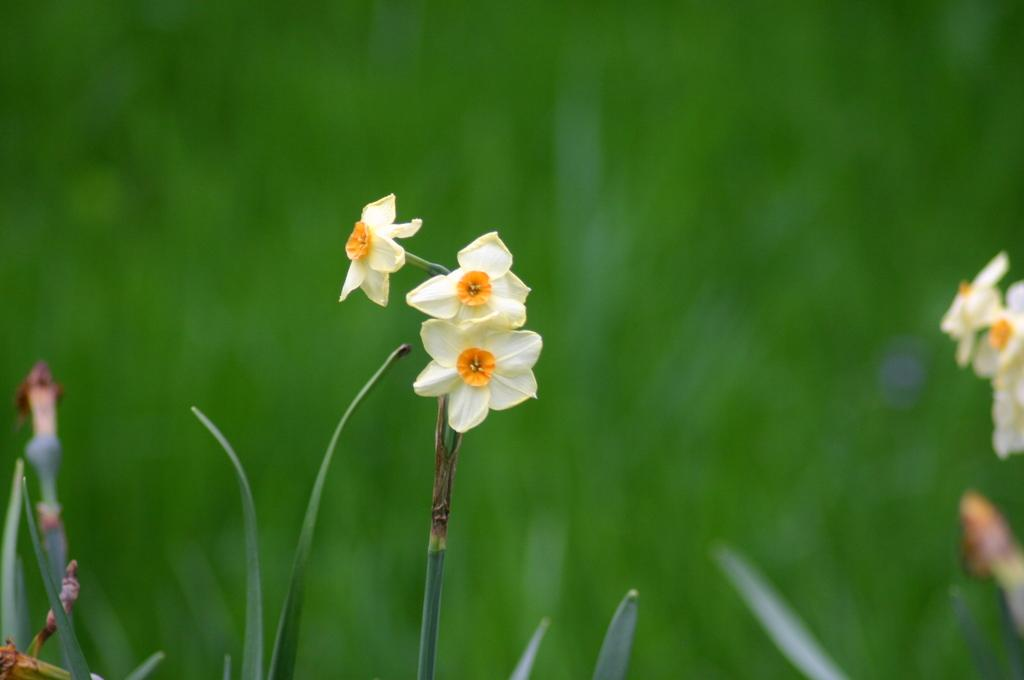What is the main subject in the middle of the image? There are flowers in the middle of the image. Can you describe the background of the image? The background of the image is blurred. What type of cream is being used by the organization in the image? There is no organization or cream present in the image; it features flowers and a blurred background. 